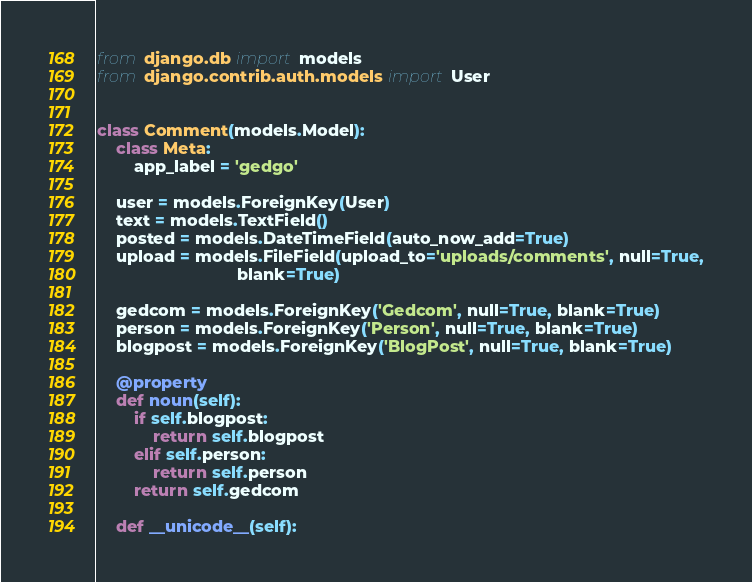<code> <loc_0><loc_0><loc_500><loc_500><_Python_>from django.db import models
from django.contrib.auth.models import User


class Comment(models.Model):
    class Meta:
        app_label = 'gedgo'

    user = models.ForeignKey(User)
    text = models.TextField()
    posted = models.DateTimeField(auto_now_add=True)
    upload = models.FileField(upload_to='uploads/comments', null=True,
                              blank=True)

    gedcom = models.ForeignKey('Gedcom', null=True, blank=True)
    person = models.ForeignKey('Person', null=True, blank=True)
    blogpost = models.ForeignKey('BlogPost', null=True, blank=True)

    @property
    def noun(self):
        if self.blogpost:
            return self.blogpost
        elif self.person:
            return self.person
        return self.gedcom

    def __unicode__(self):</code> 